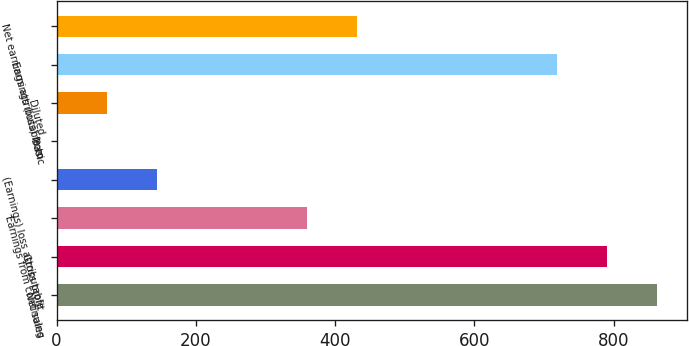<chart> <loc_0><loc_0><loc_500><loc_500><bar_chart><fcel>Net sales<fcel>Gross profit<fcel>Earnings from continuing<fcel>(Earnings) loss attributable<fcel>Basic<fcel>Diluted<fcel>Earnings (loss) from<fcel>Net earnings attributable to<nl><fcel>861.74<fcel>789.93<fcel>359.07<fcel>143.64<fcel>0.02<fcel>71.83<fcel>718.12<fcel>430.88<nl></chart> 